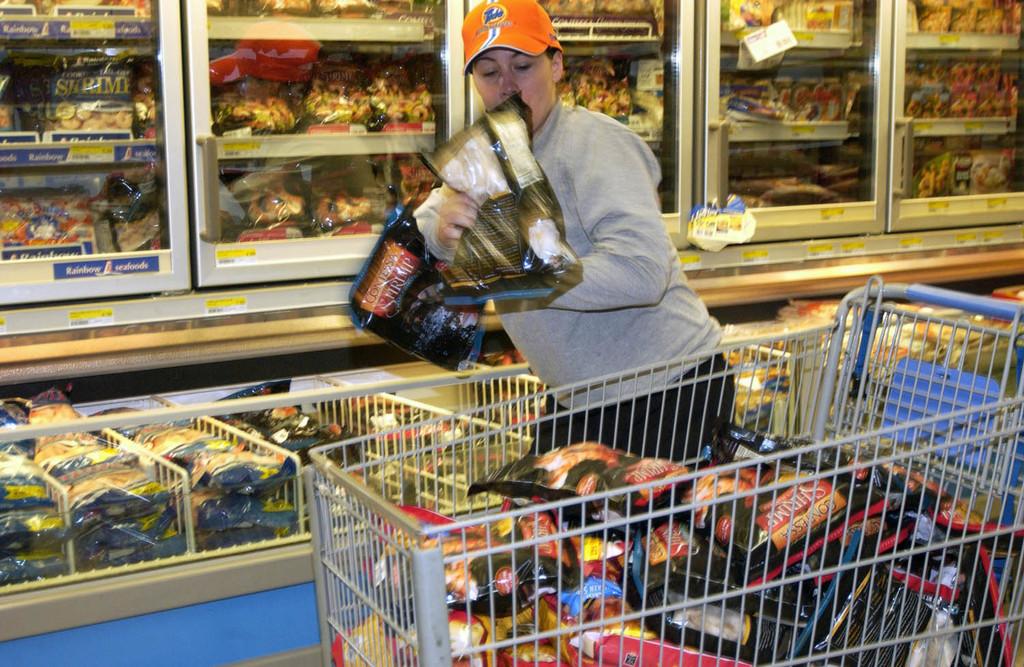Name one of the brands shown in this store?
Your answer should be compact. Contessa. 